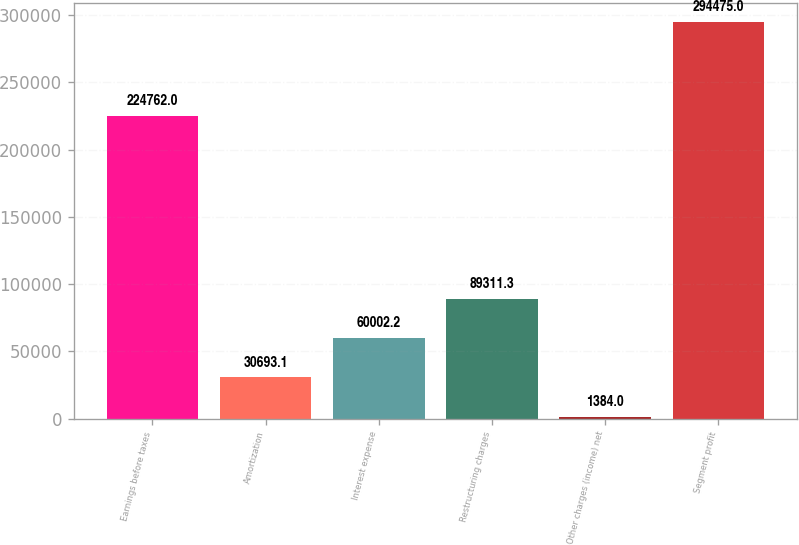<chart> <loc_0><loc_0><loc_500><loc_500><bar_chart><fcel>Earnings before taxes<fcel>Amortization<fcel>Interest expense<fcel>Restructuring charges<fcel>Other charges (income) net<fcel>Segment profit<nl><fcel>224762<fcel>30693.1<fcel>60002.2<fcel>89311.3<fcel>1384<fcel>294475<nl></chart> 